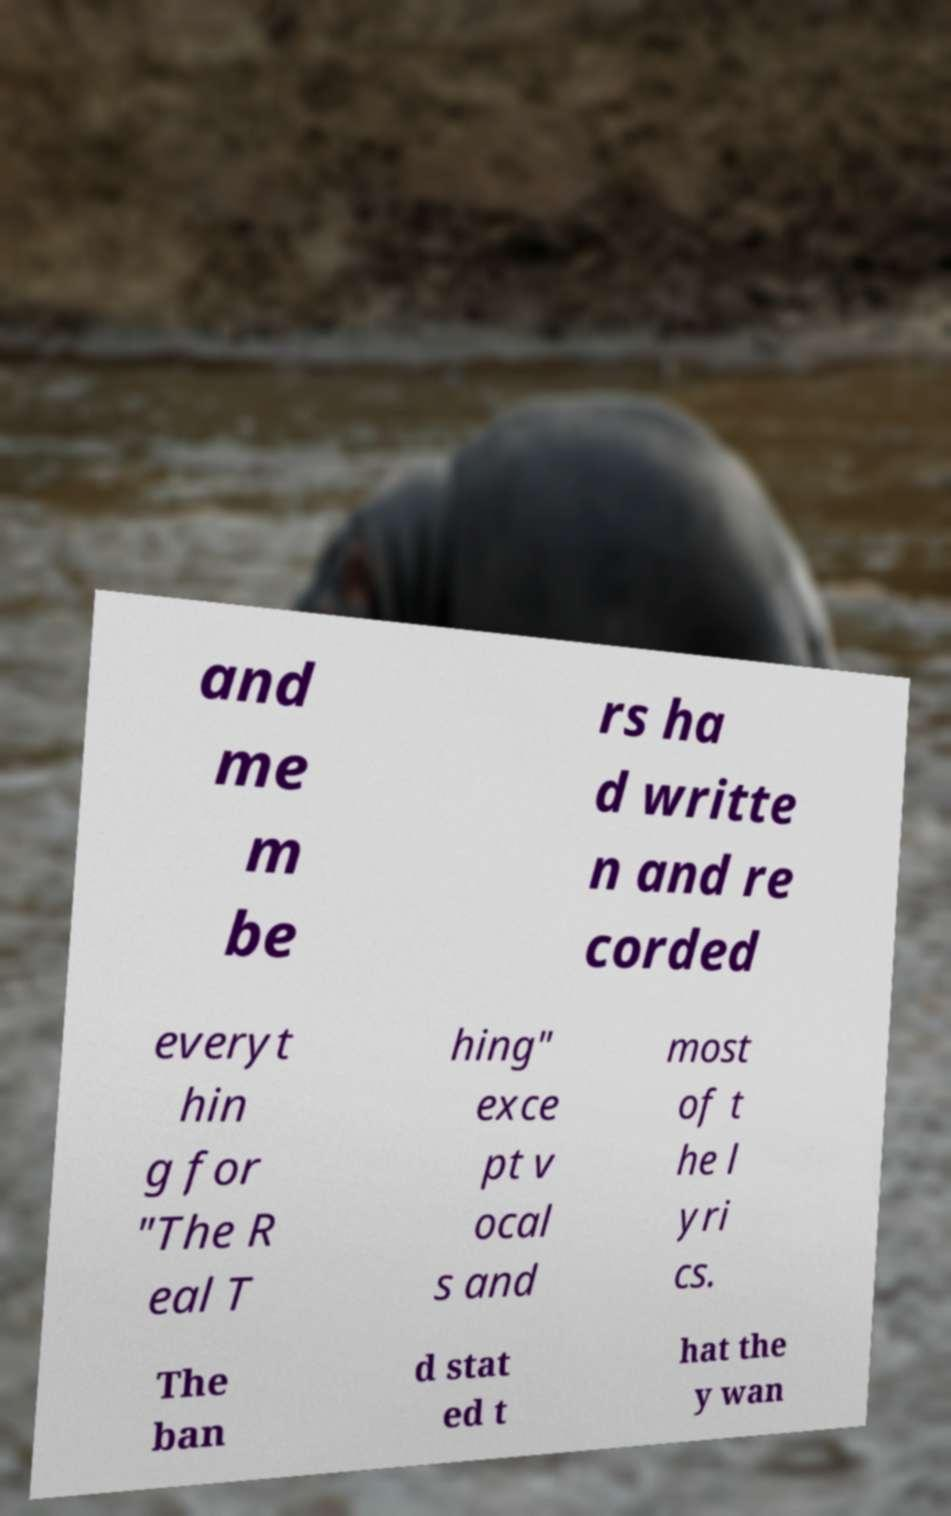Could you assist in decoding the text presented in this image and type it out clearly? and me m be rs ha d writte n and re corded everyt hin g for "The R eal T hing" exce pt v ocal s and most of t he l yri cs. The ban d stat ed t hat the y wan 